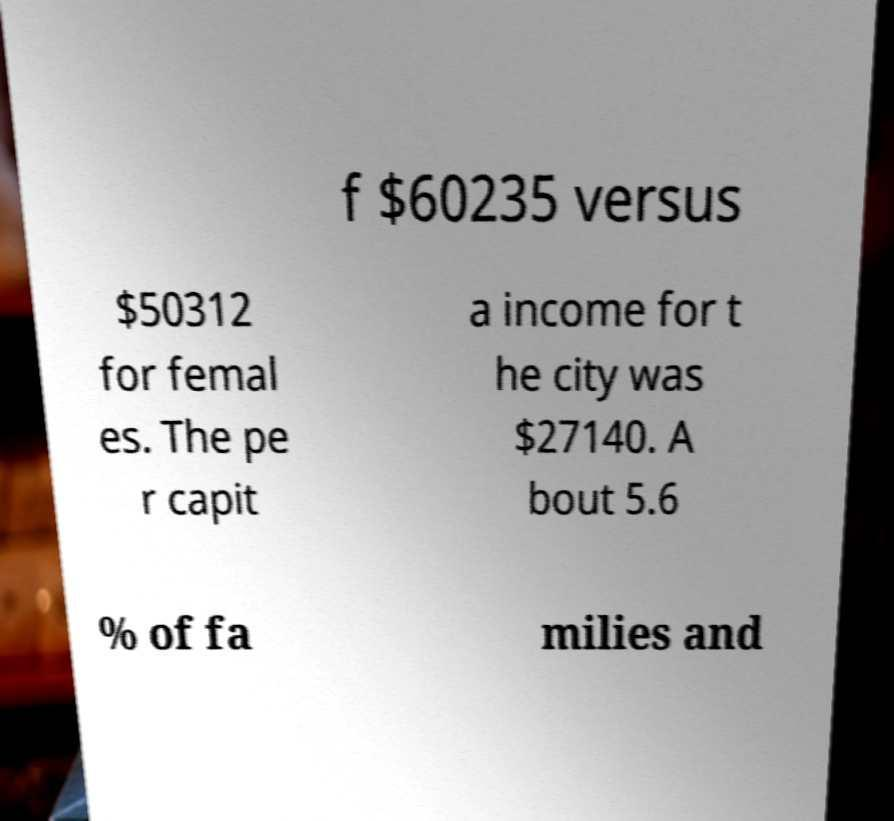Please read and relay the text visible in this image. What does it say? f $60235 versus $50312 for femal es. The pe r capit a income for t he city was $27140. A bout 5.6 % of fa milies and 